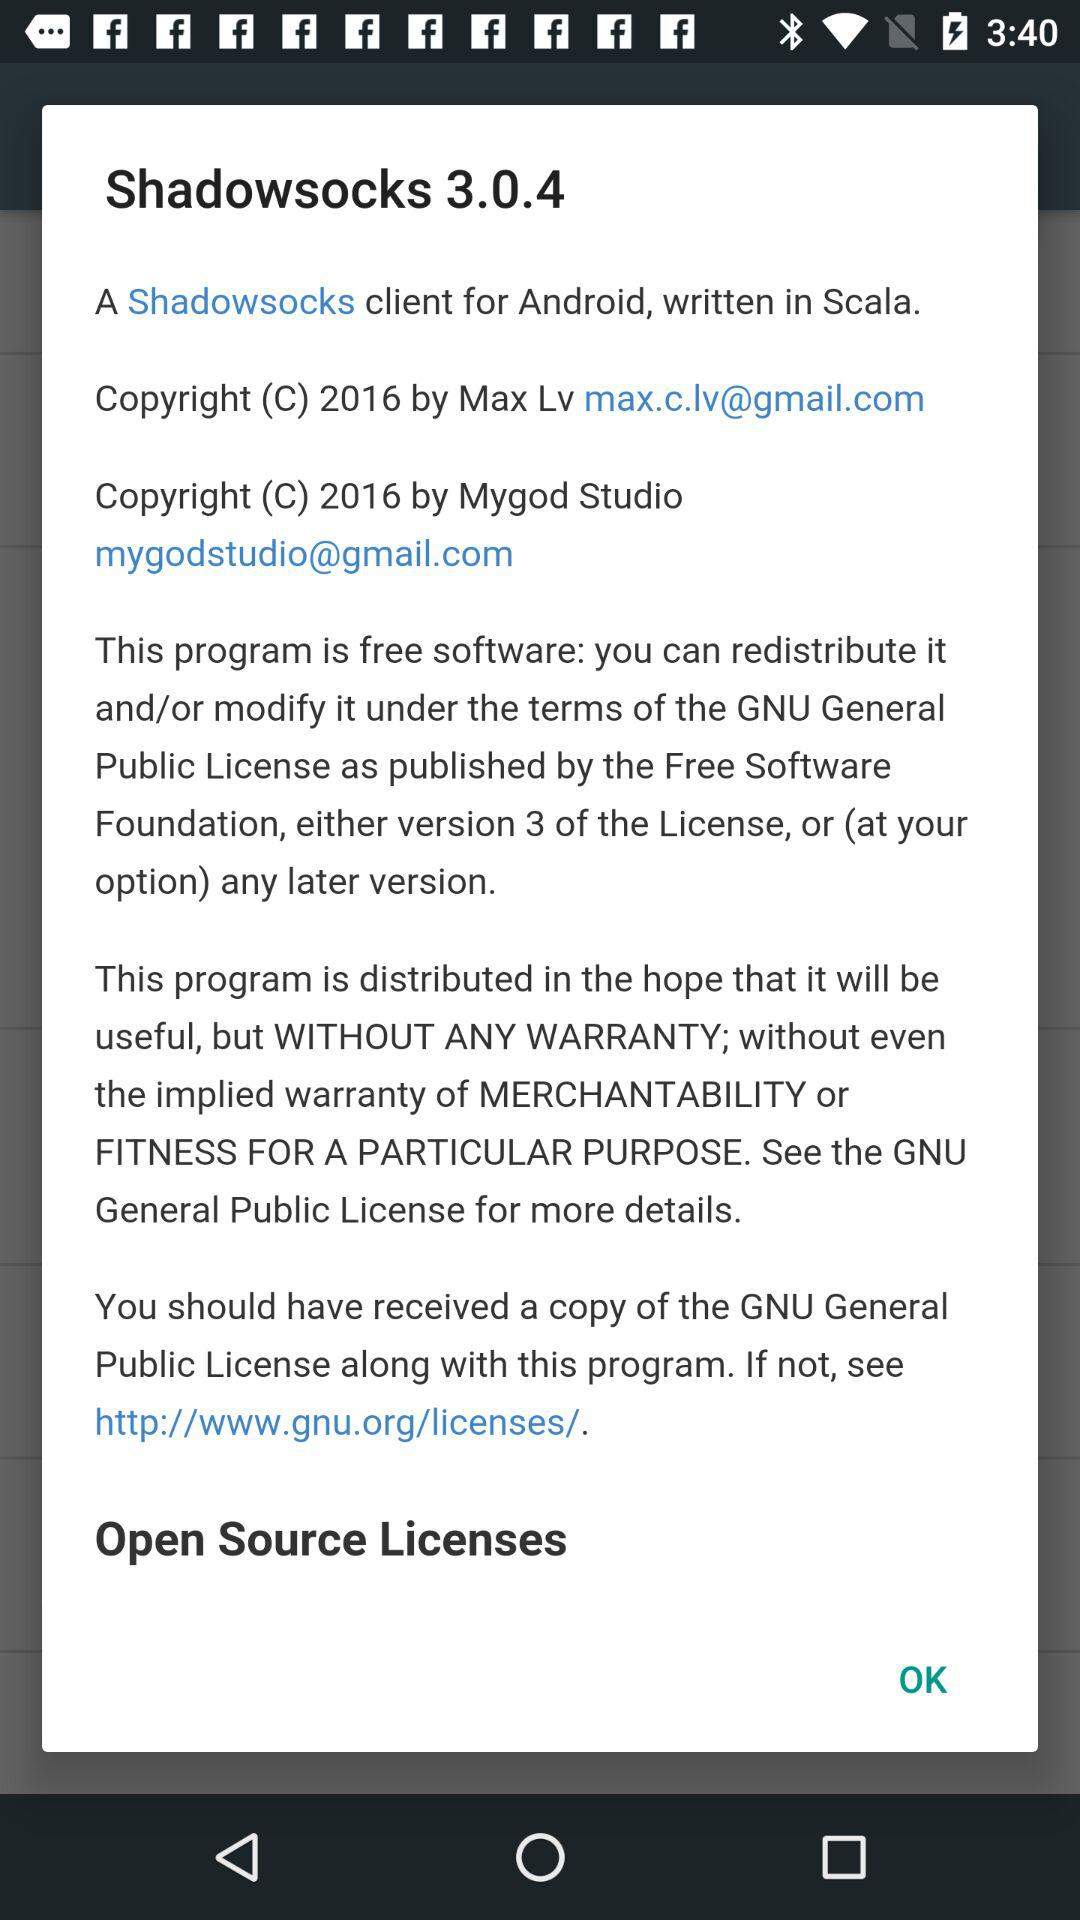What is the name of the application? The name of the application is "Shadowsocks". 